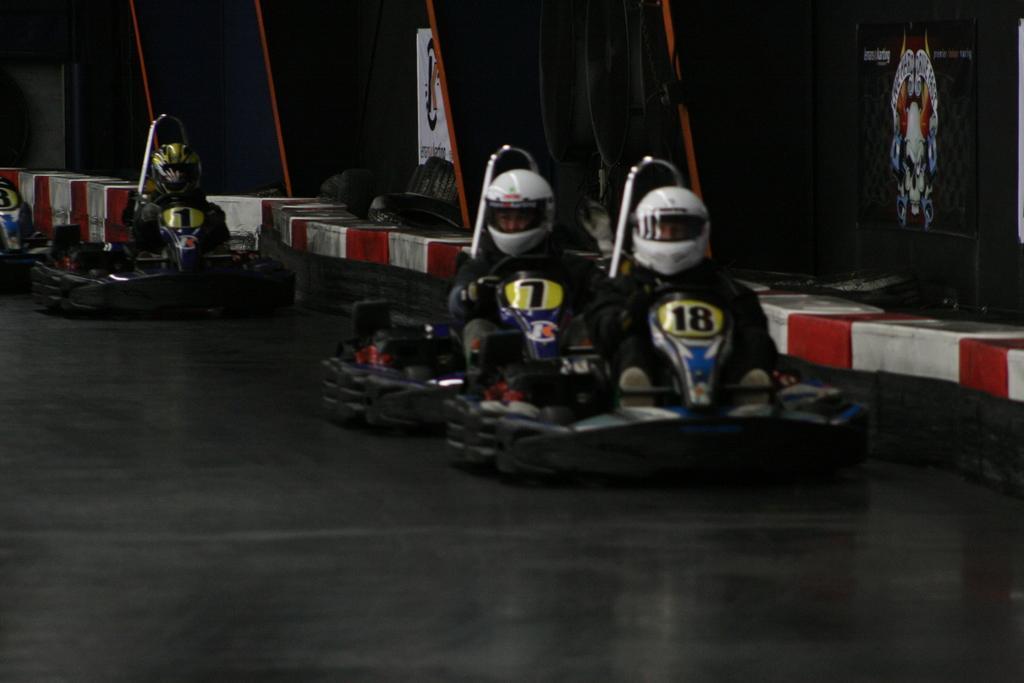Describe this image in one or two sentences. In this image there are few peoples wearing helmets sitting vehicles visible on floor, beside them there are some objects visible. 